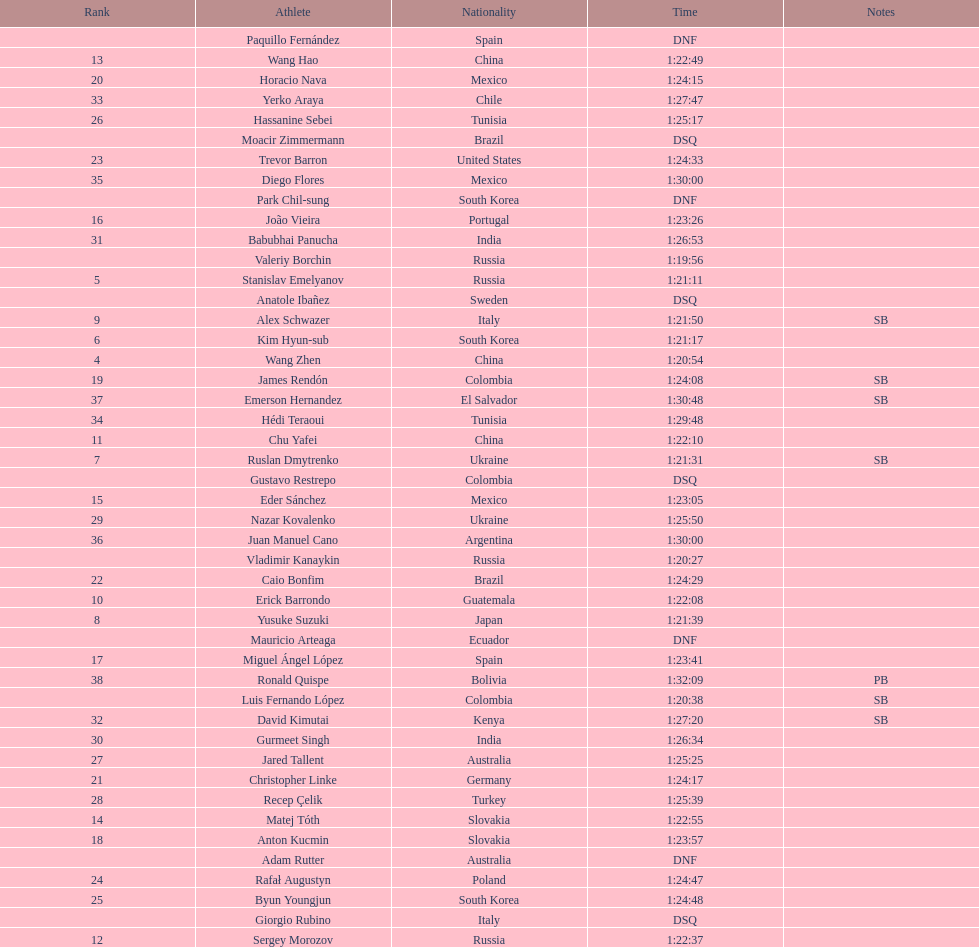Which chinese athlete had the fastest time? Wang Zhen. 